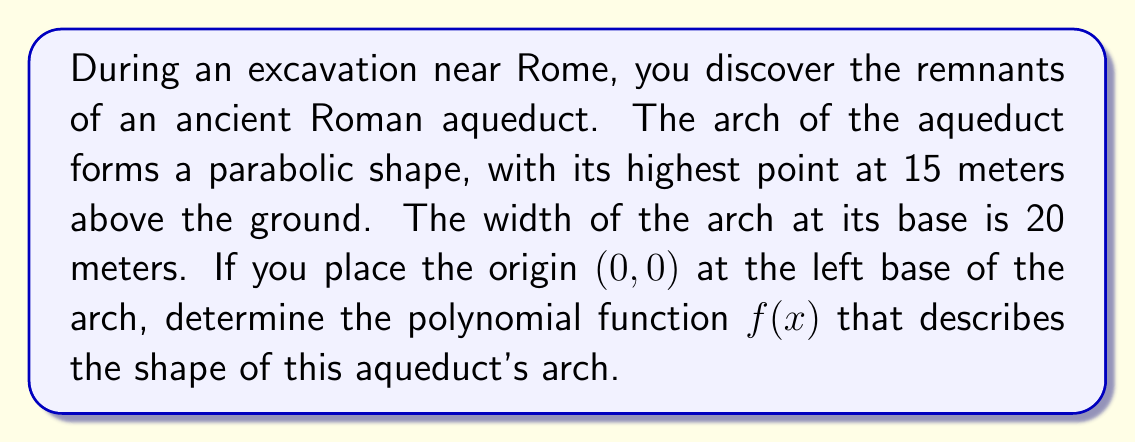Help me with this question. Let's approach this step-by-step:

1) We know the arch forms a parabola, so the general form of the function will be:
   $f(x) = a(x-h)^2 + k$
   where (h,k) is the vertex of the parabola.

2) The arch is symmetric, so the vertex will be at the center of the base. Since the width is 20 meters:
   $h = 10$

3) The height of the arch is 15 meters, so:
   $k = 15$

4) Now our function looks like:
   $f(x) = a(x-10)^2 + 15$

5) To find $a$, we can use the fact that the function should equal 0 when $x = 0$ (left base):
   $0 = a(0-10)^2 + 15$
   $0 = 100a + 15$
   $-15 = 100a$
   $a = -\frac{15}{100} = -0.15$

6) Therefore, our final function is:
   $f(x) = -0.15(x-10)^2 + 15$

7) We can expand this to standard form:
   $f(x) = -0.15(x^2 - 20x + 100) + 15$
   $f(x) = -0.15x^2 + 3x - 15 + 15$
   $f(x) = -0.15x^2 + 3x$

[asy]
import graph;
size(200,150);
real f(real x) {return -0.15*x^2 + 3*x;}
draw(graph(f,0,20),blue);
xaxis("x",arrow=Arrow);
yaxis("y",arrow=Arrow);
label("15m",(10,15),N);
label("20m",(20,0),S);
[/asy]
Answer: $f(x) = -0.15x^2 + 3x$ 